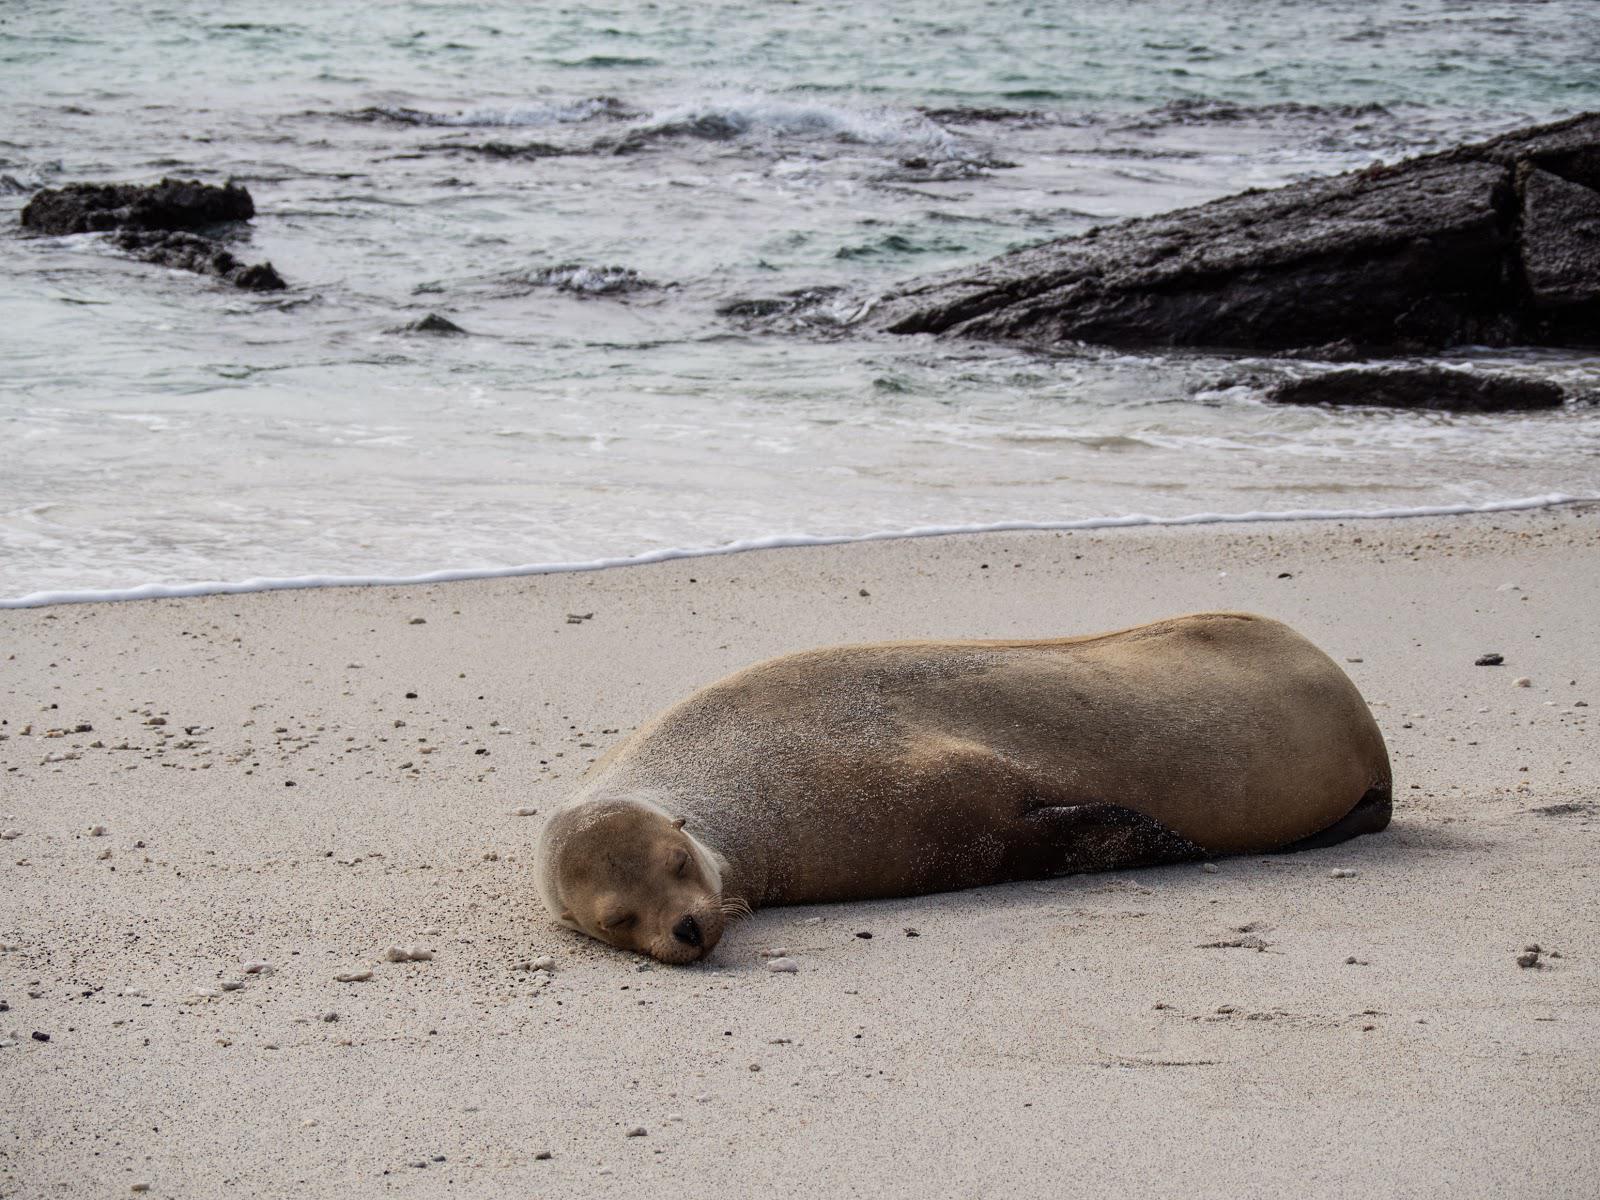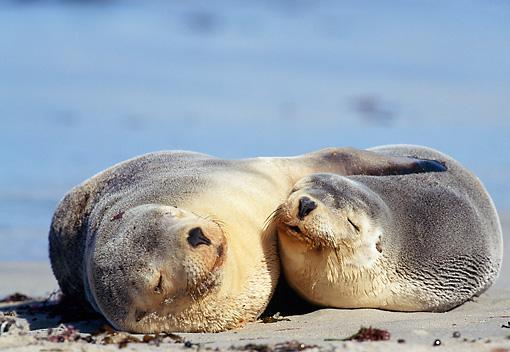The first image is the image on the left, the second image is the image on the right. For the images displayed, is the sentence "Two seals are lying in the sand in the image on the right." factually correct? Answer yes or no. Yes. 